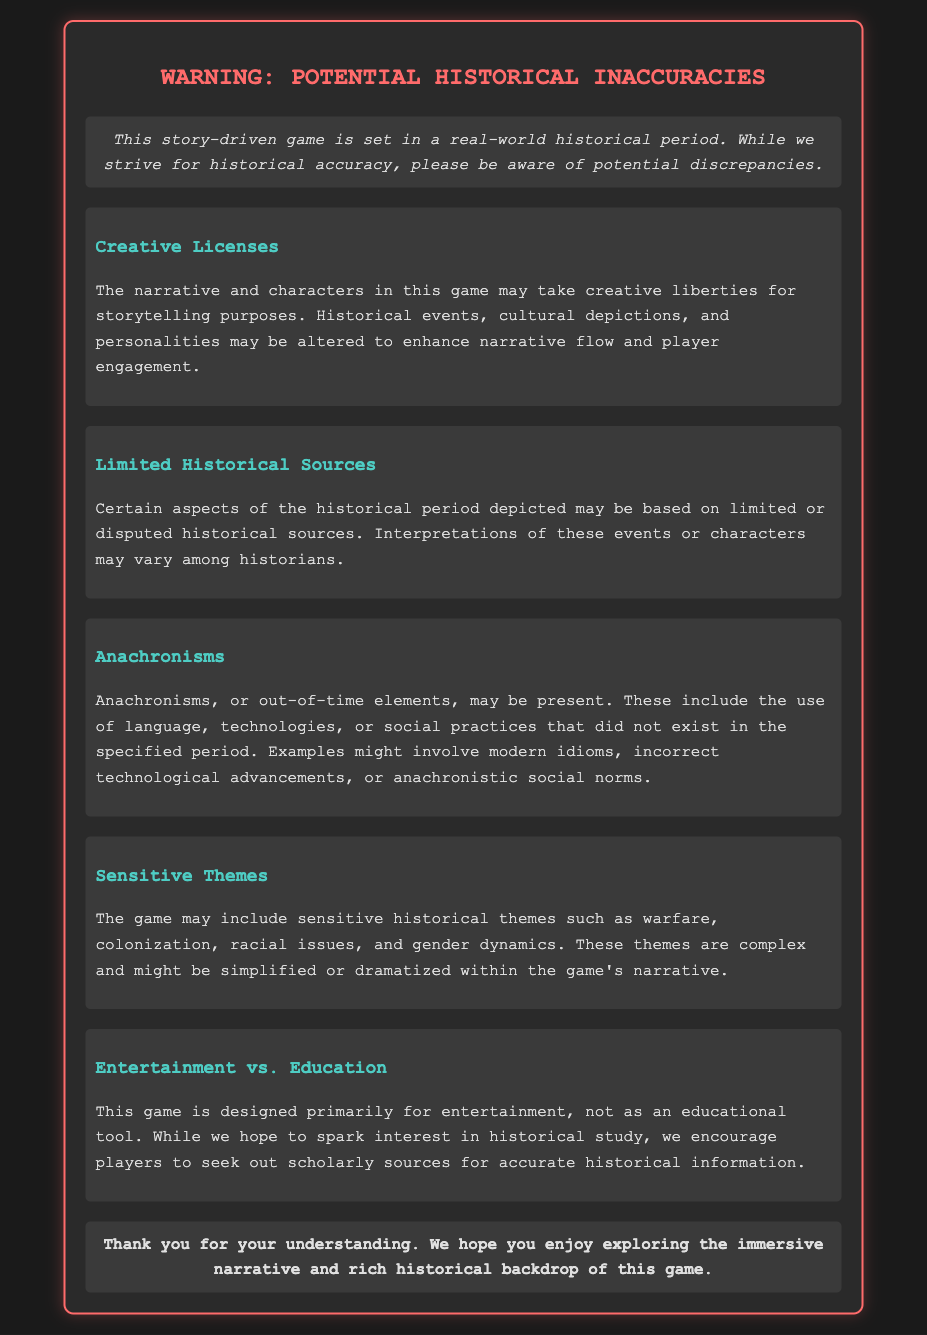What is the main warning about? The document warns about potential historical inaccuracies in a story-driven game set in a real-world historical period.
Answer: Potential historical inaccuracies What is one reason for historical inaccuracies mentioned? The document states that the narrative and characters may take creative liberties for storytelling purposes, which might alter historical events.
Answer: Creative liberties What does the section on "Limited Historical Sources" mention? It mentions that certain aspects may be based on limited or disputed historical sources and that interpretations may vary among historians.
Answer: Limited or disputed historical sources What does "Anachronisms" refer to in the document? Anachronisms refer to out-of-time elements such as language, technologies, or social practices that did not exist in the specified period.
Answer: Out-of-time elements What is the primary purpose of the game according to the warning label? The game is primarily designed for entertainment, not as an educational tool.
Answer: Entertainment What theme is specifically mentioned as potentially being included in the game? The document mentions sensitive historical themes such as warfare, colonization, racial issues, and gender dynamics.
Answer: Warfare, colonization, racial issues, and gender dynamics How does the document suggest players should approach historical information? The document encourages players to seek out scholarly sources for accurate historical information.
Answer: Seek out scholarly sources What color are the headings in the warning label? The headings in the warning label are colored in a shade of teal.
Answer: Teal What is the final statement of the warning label? The final statement thanks players for their understanding and expresses hope that they enjoy the game.
Answer: Thank you for your understanding 